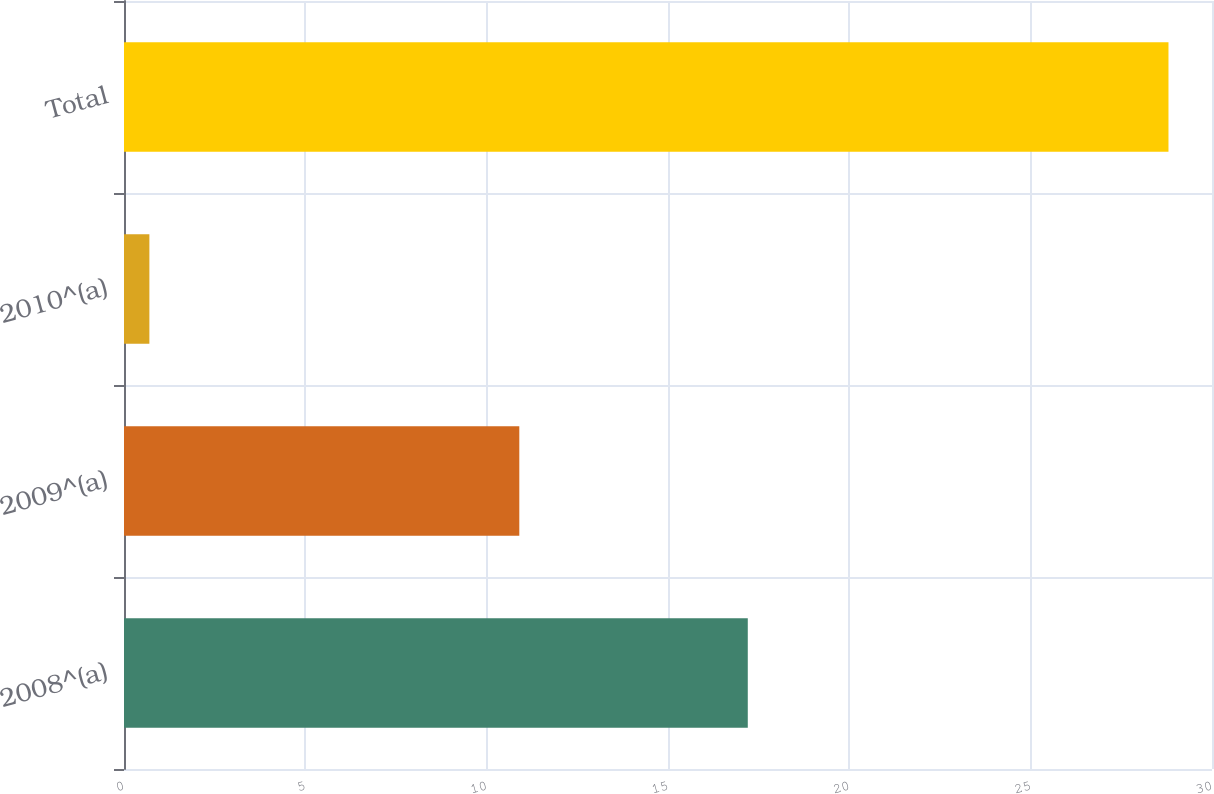<chart> <loc_0><loc_0><loc_500><loc_500><bar_chart><fcel>2008^(a)<fcel>2009^(a)<fcel>2010^(a)<fcel>Total<nl><fcel>17.2<fcel>10.9<fcel>0.7<fcel>28.8<nl></chart> 